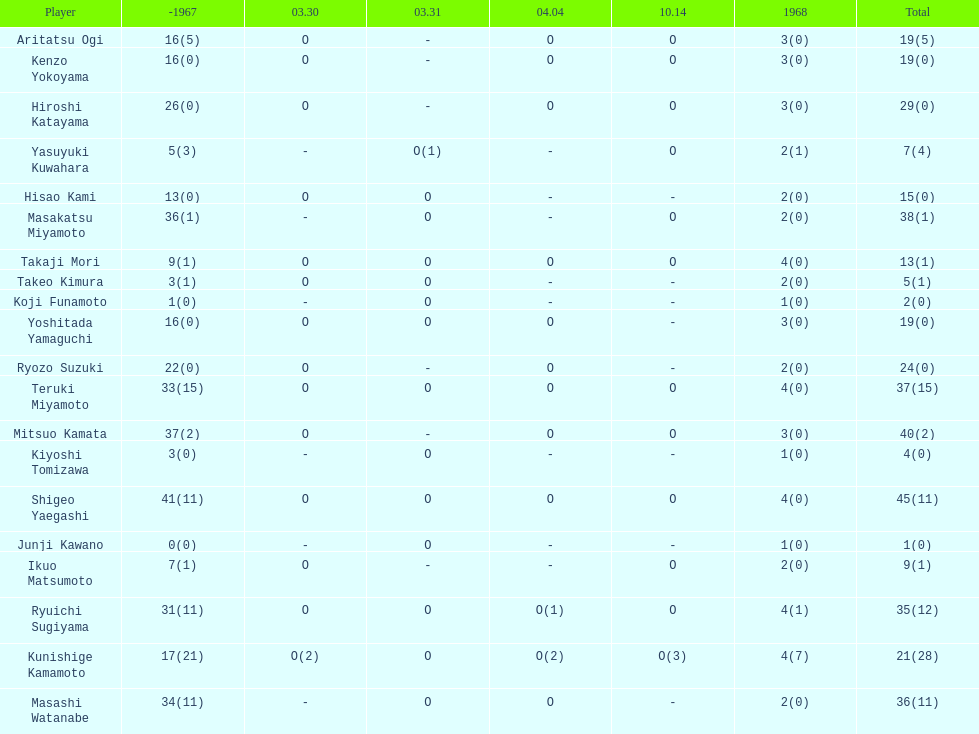Who had more points takaji mori or junji kawano? Takaji Mori. 